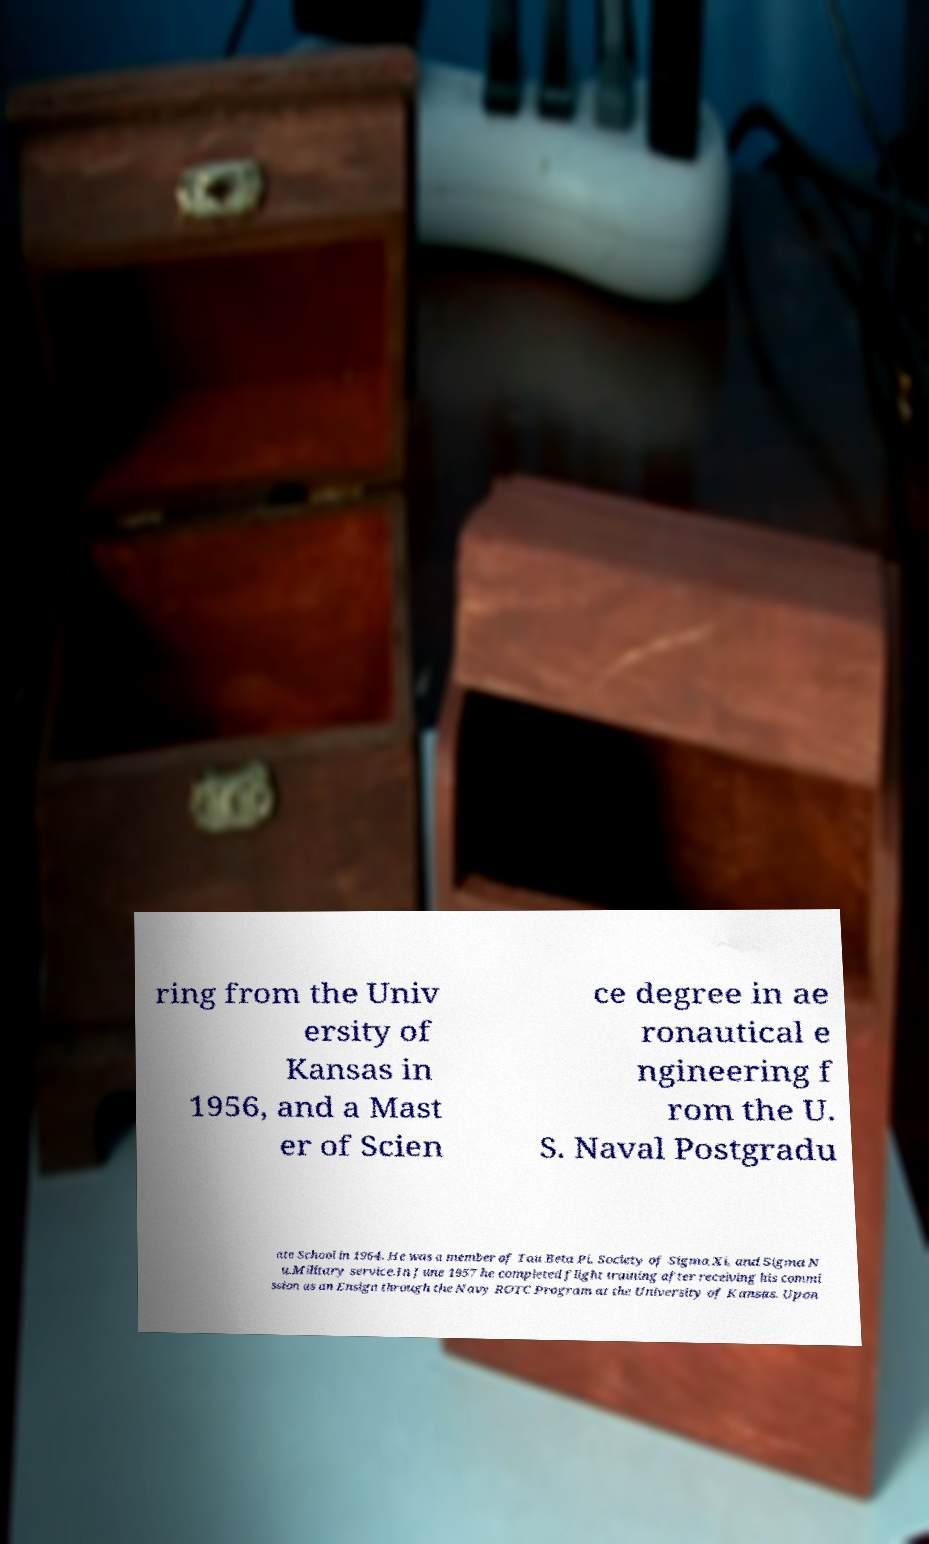Could you assist in decoding the text presented in this image and type it out clearly? ring from the Univ ersity of Kansas in 1956, and a Mast er of Scien ce degree in ae ronautical e ngineering f rom the U. S. Naval Postgradu ate School in 1964. He was a member of Tau Beta Pi, Society of Sigma Xi, and Sigma N u.Military service.In June 1957 he completed flight training after receiving his commi ssion as an Ensign through the Navy ROTC Program at the University of Kansas. Upon 